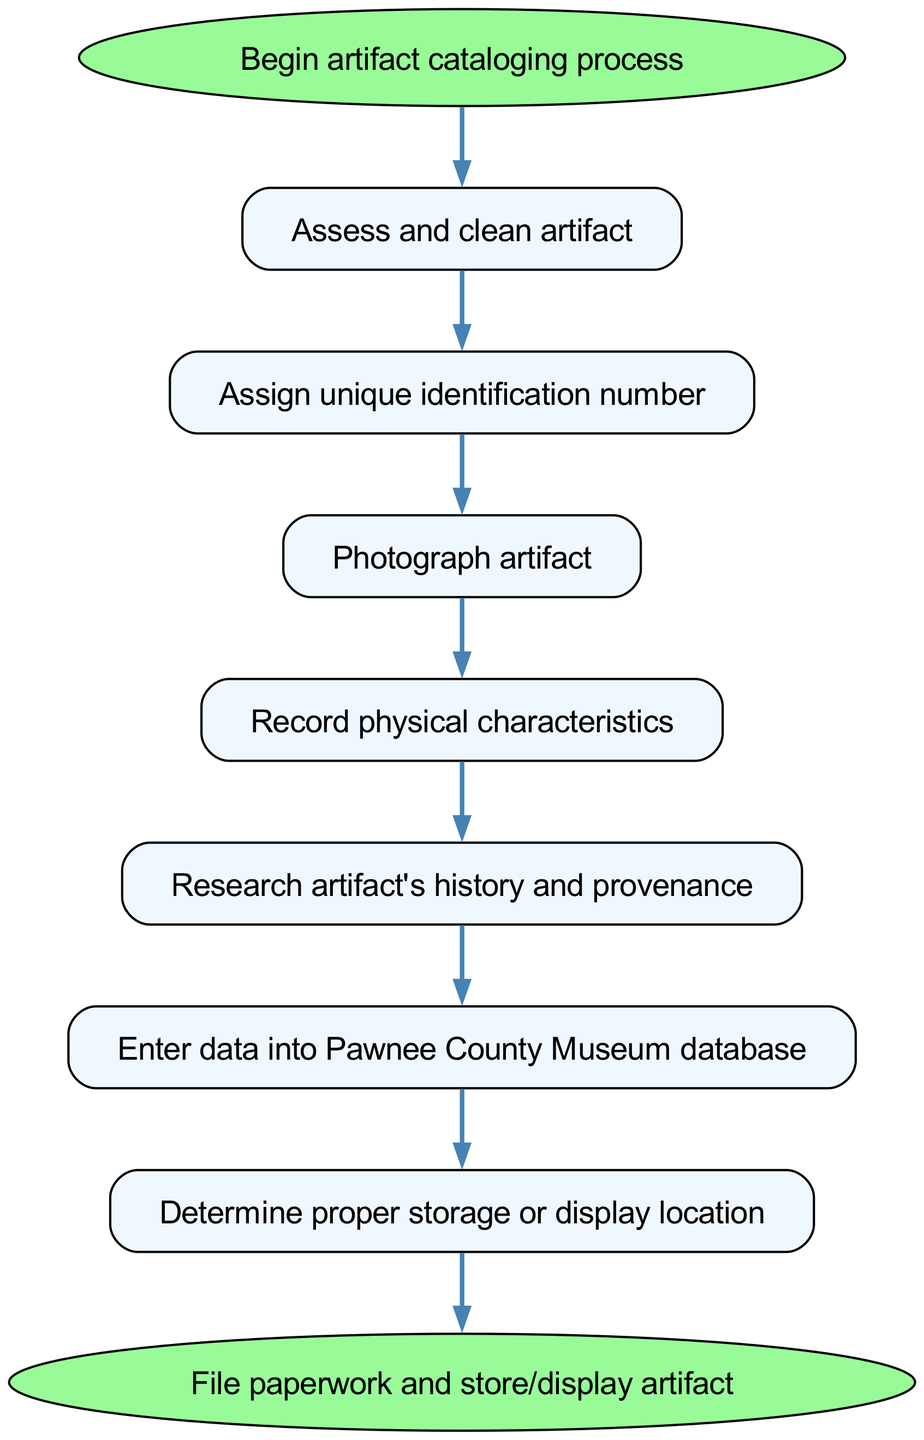What is the first step in the artifact cataloging process? The first step is indicated by the "start" node, which points directly to "Assess and clean artifact." Therefore, the first step in the process is to assess and clean the artifact.
Answer: Assess and clean artifact How many unique steps are there in the diagram? By counting the nodes listed as steps between the "start" and "end" nodes, there are seven steps: assess, assign, photograph, record, research, enter data, and determine storage. Therefore, the total number of unique steps is seven.
Answer: Seven What follows after photographing the artifact? The flow of the diagram shows that after the "Photograph artifact" step, the next step is "Record physical characteristics." This indicates the sequential order of the process as presented in the diagram.
Answer: Record physical characteristics Which step comes before entering data into the database? The step immediately before "Enter data into Pawnee County Museum database" is "Research artifact's history and provenance." This indicates the order in which the steps need to be followed in the cataloging process.
Answer: Research artifact's history and provenance What is the last step indicated in the artifact cataloging process? The last step is found at the "end" node, which states "File paperwork and store/display artifact." This signifies the conclusion of the cataloging process as detailed in the diagram.
Answer: File paperwork and store/display artifact In which step is a unique identification number assigned? The step where the unique identification number is assigned is "Assign unique identification number." This is directly revealed in the flow chart sequence, confirming when this action takes place.
Answer: Assign unique identification number What is the relationship between the steps for cleaning and displaying artifacts? Cleaning the artifact is the first step in the process, while displaying it is the concluding action. In the sequence, after cleaning, several steps occur before the final action of storing or displaying the artifact. Hence, the relationship is primarily sequential.
Answer: Sequential After determining the proper storage or display location, what is the next action? The flow chart shows that after "Determine proper storage or display location," the next action is to "File paperwork and store/display artifact." This indicates the continuation of actions that follow determining storage or display.
Answer: File paperwork and store/display artifact 